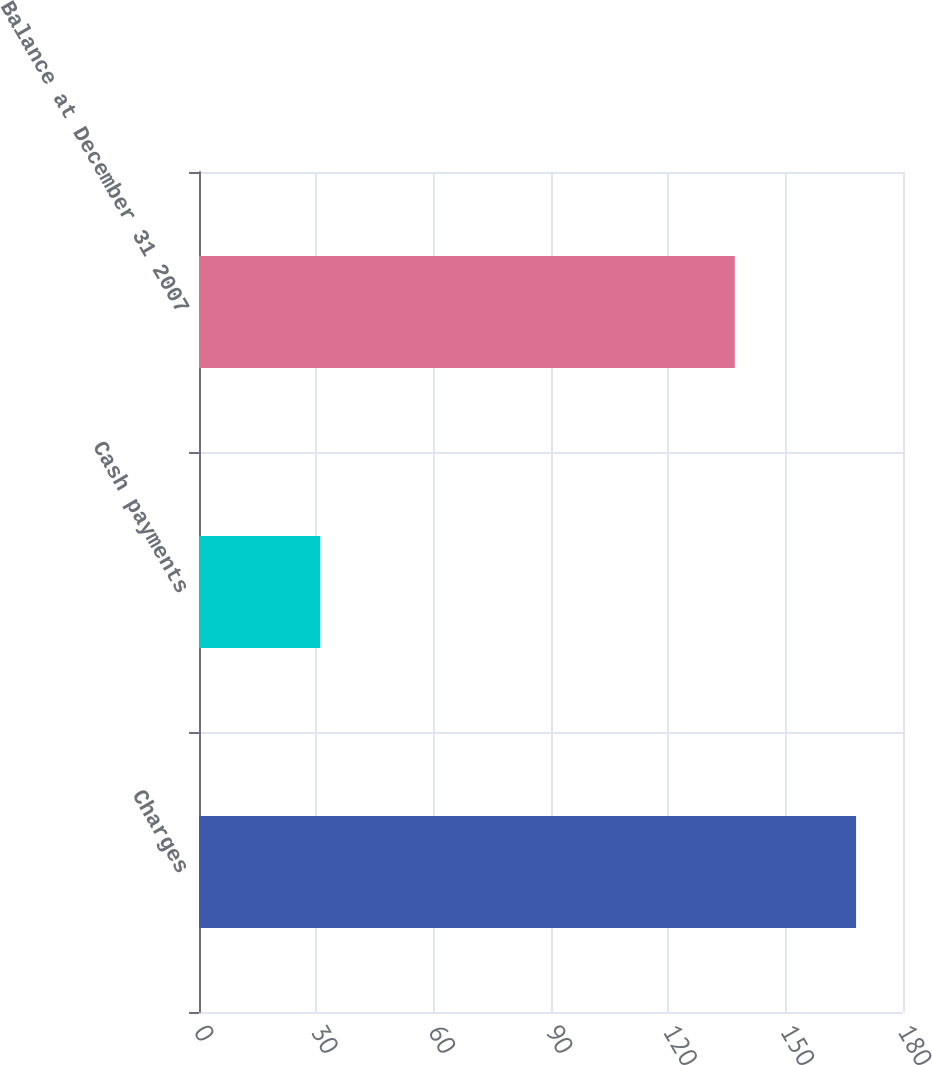Convert chart. <chart><loc_0><loc_0><loc_500><loc_500><bar_chart><fcel>Charges<fcel>Cash payments<fcel>Balance at December 31 2007<nl><fcel>168<fcel>31<fcel>137<nl></chart> 